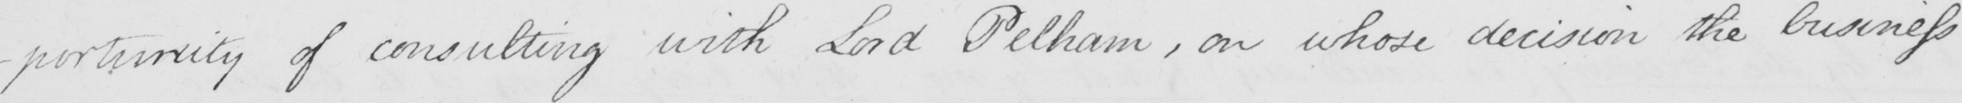Please transcribe the handwritten text in this image. -portunity of consulting with Lord Pelham , on whose decision the business 